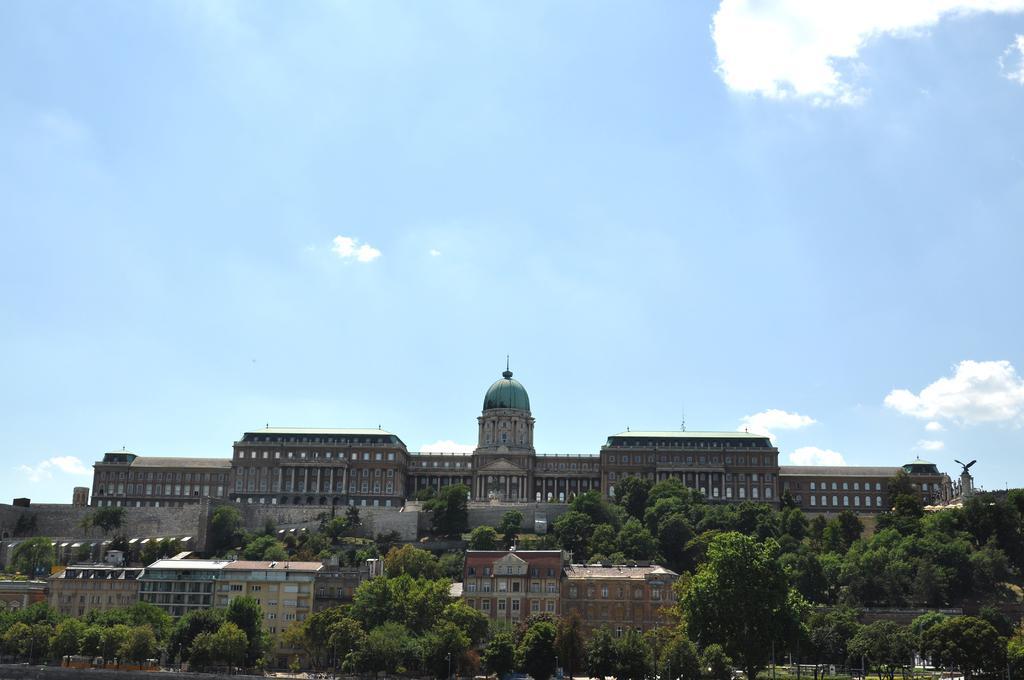In one or two sentences, can you explain what this image depicts? In this image there are buildings, in front of the building there are trees. In the background there is the sky. 